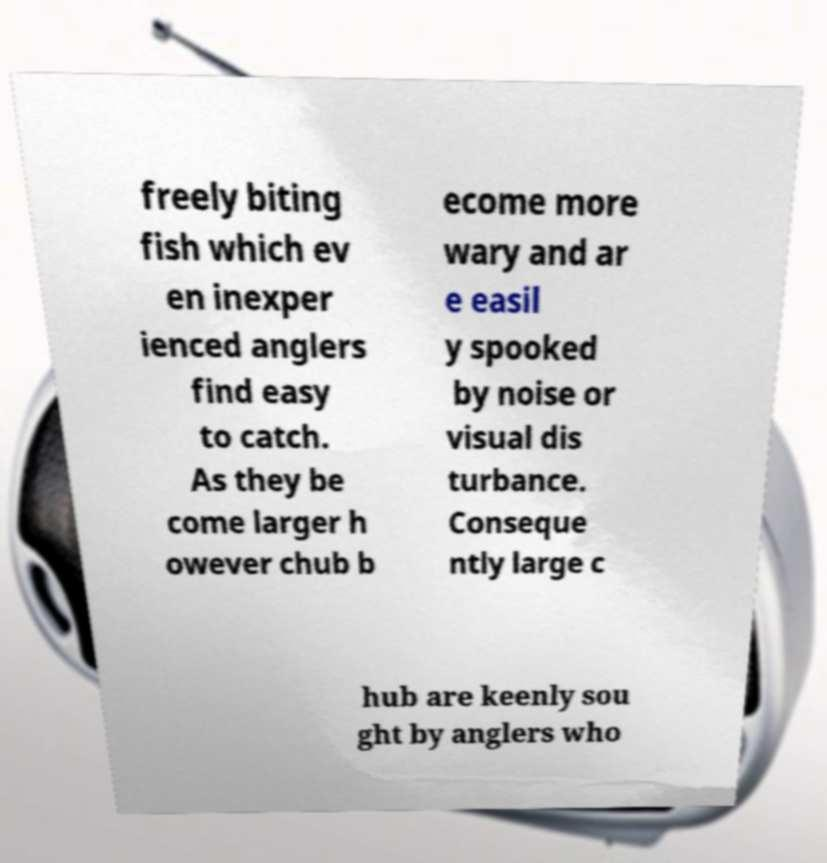Can you accurately transcribe the text from the provided image for me? freely biting fish which ev en inexper ienced anglers find easy to catch. As they be come larger h owever chub b ecome more wary and ar e easil y spooked by noise or visual dis turbance. Conseque ntly large c hub are keenly sou ght by anglers who 